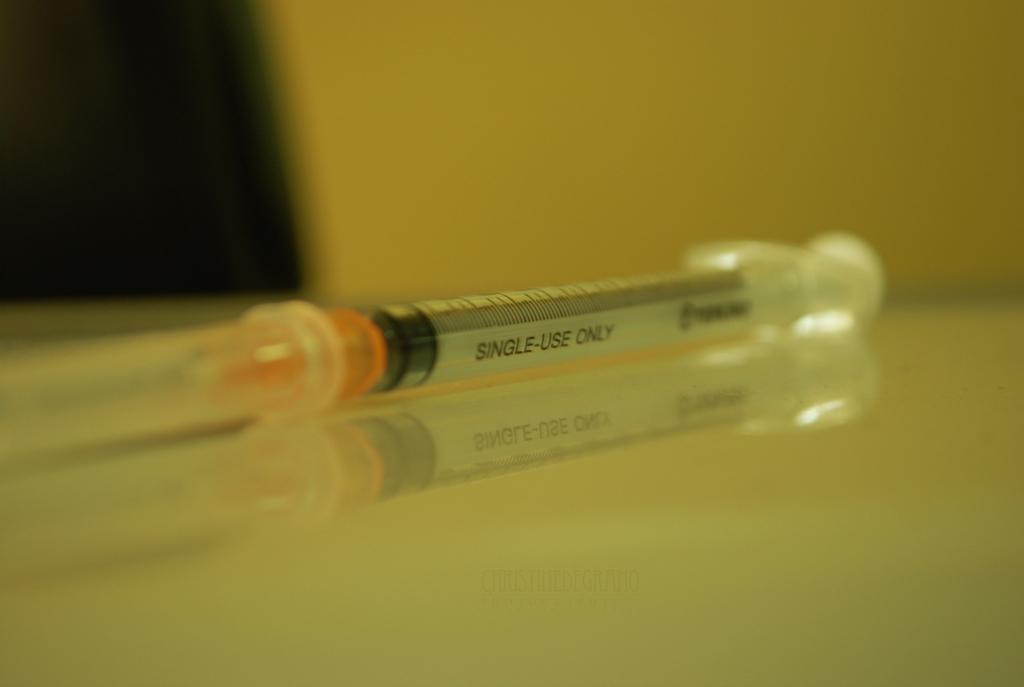What is the main subject of the image? The main subject of the image is an injection. What color is the surface on which the injection is placed? The injection is on a cream-colored surface. Can you describe the background of the image? The background of the image has yellow and brown colors. What type of plough is being used by the servant in the image? There is no plough or servant present in the image; it only features an injection on a cream-colored surface with a yellow and brown background. 